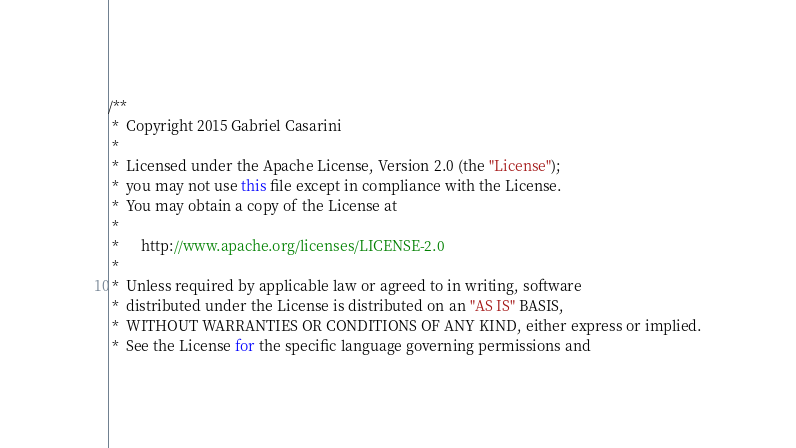<code> <loc_0><loc_0><loc_500><loc_500><_Java_>/**
 *  Copyright 2015 Gabriel Casarini
 *  
 *  Licensed under the Apache License, Version 2.0 (the "License");
 *  you may not use this file except in compliance with the License.
 *  You may obtain a copy of the License at
 *  
 *      http://www.apache.org/licenses/LICENSE-2.0
 *  
 *  Unless required by applicable law or agreed to in writing, software
 *  distributed under the License is distributed on an "AS IS" BASIS,
 *  WITHOUT WARRANTIES OR CONDITIONS OF ANY KIND, either express or implied.
 *  See the License for the specific language governing permissions and</code> 